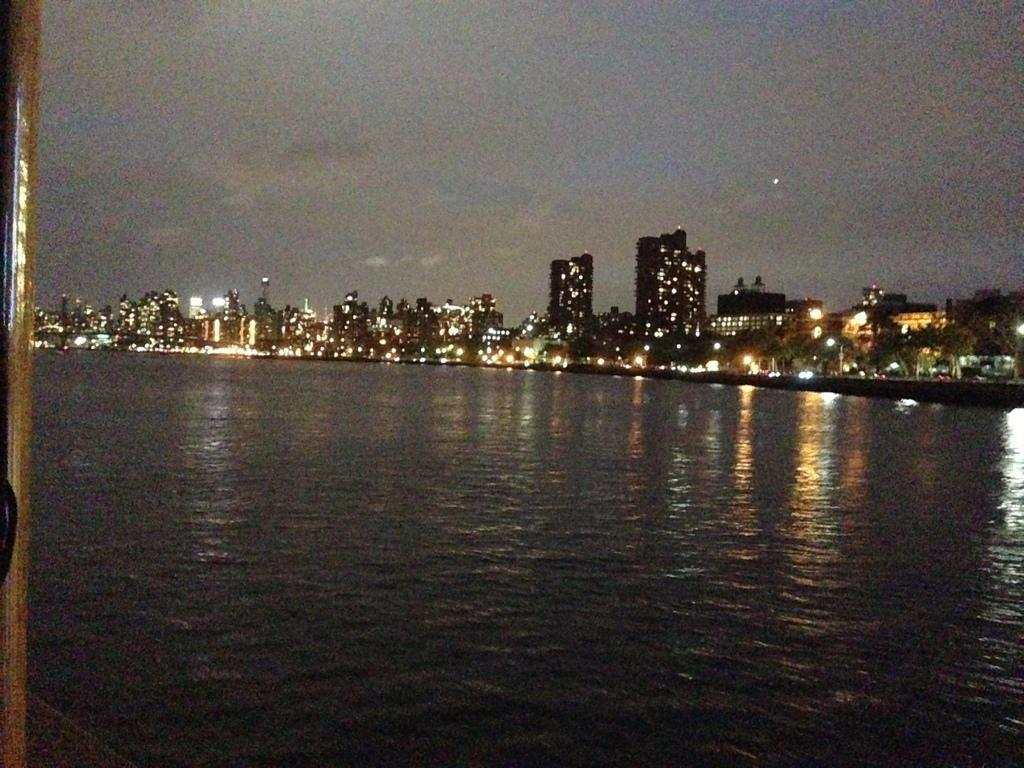What type of structures can be seen in the image? There are buildings in the image. What else is visible in the image besides the buildings? There are lights, poles, trees, water, and the sky visible in the image. Can you describe the object on the left side of the image? Unfortunately, the provided facts do not give enough information to describe the object on the left side of the image. What natural elements are present in the image? Trees and water are the natural elements present in the image. What type of mint is growing on the poles in the image? There is no mint growing on the poles in the image; the provided facts only mention lights and poles. How much does the underwear weigh on the scale in the image? There is no underwear or scale present in the image. 